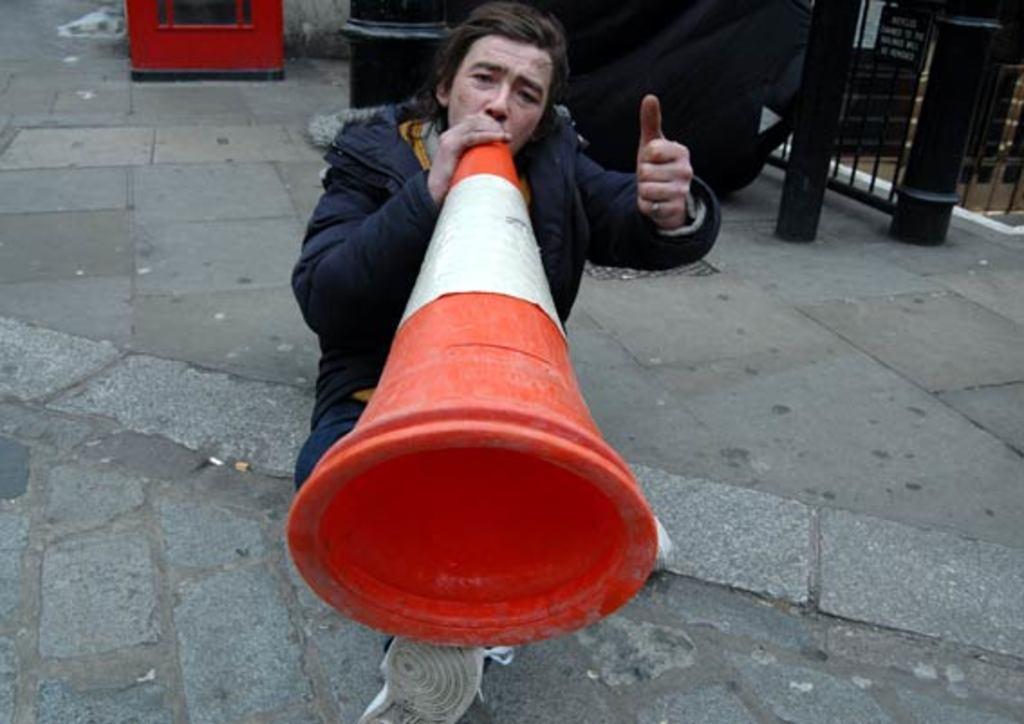In one or two sentences, can you explain what this image depicts? In this image, we can see a person wearing clothes and holding a divider cone with his hand. There are poles in the top right of the image. 